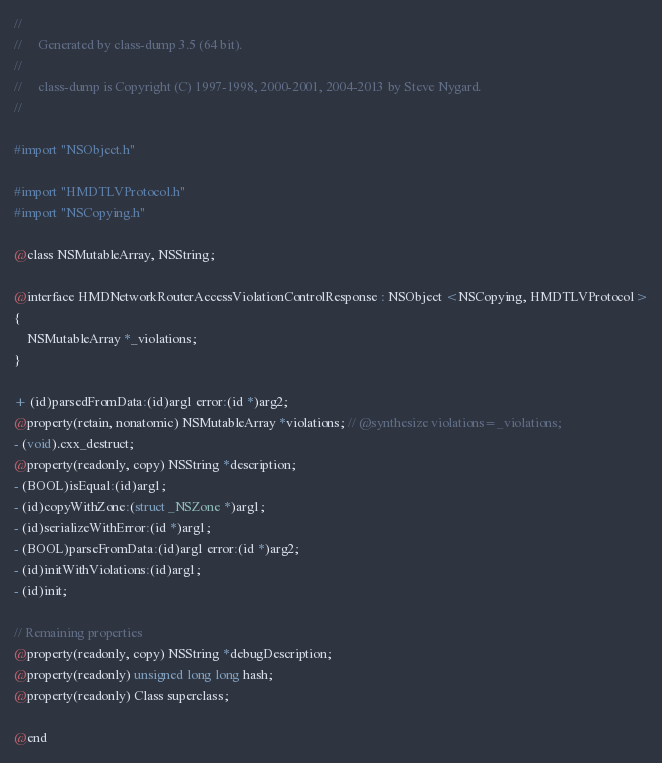Convert code to text. <code><loc_0><loc_0><loc_500><loc_500><_C_>//
//     Generated by class-dump 3.5 (64 bit).
//
//     class-dump is Copyright (C) 1997-1998, 2000-2001, 2004-2013 by Steve Nygard.
//

#import "NSObject.h"

#import "HMDTLVProtocol.h"
#import "NSCopying.h"

@class NSMutableArray, NSString;

@interface HMDNetworkRouterAccessViolationControlResponse : NSObject <NSCopying, HMDTLVProtocol>
{
    NSMutableArray *_violations;
}

+ (id)parsedFromData:(id)arg1 error:(id *)arg2;
@property(retain, nonatomic) NSMutableArray *violations; // @synthesize violations=_violations;
- (void).cxx_destruct;
@property(readonly, copy) NSString *description;
- (BOOL)isEqual:(id)arg1;
- (id)copyWithZone:(struct _NSZone *)arg1;
- (id)serializeWithError:(id *)arg1;
- (BOOL)parseFromData:(id)arg1 error:(id *)arg2;
- (id)initWithViolations:(id)arg1;
- (id)init;

// Remaining properties
@property(readonly, copy) NSString *debugDescription;
@property(readonly) unsigned long long hash;
@property(readonly) Class superclass;

@end

</code> 